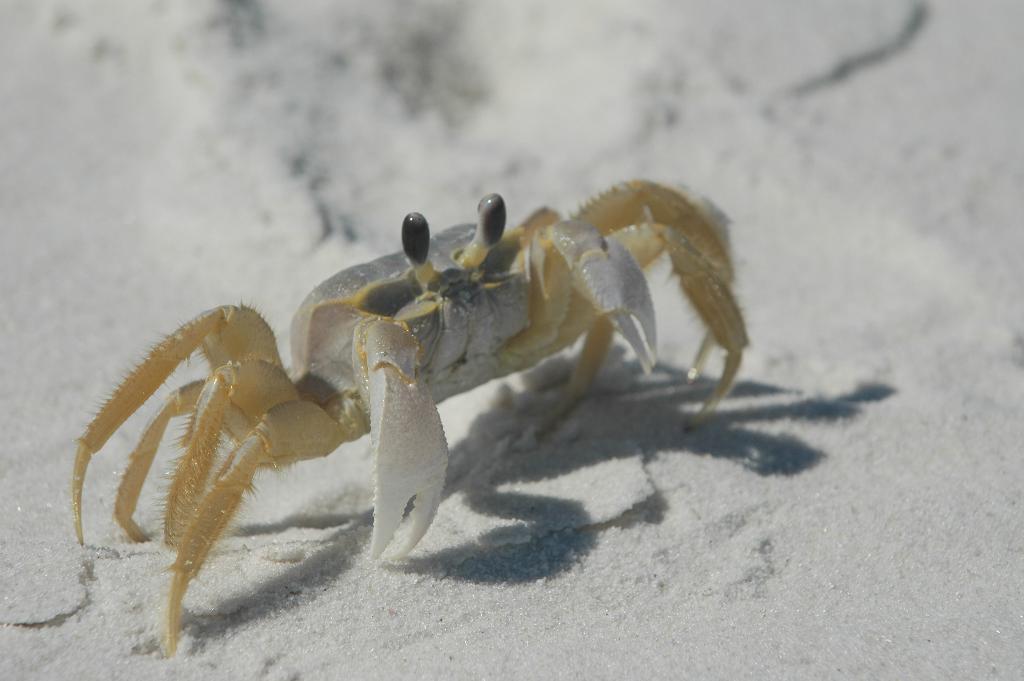Can you describe this image briefly? The picture consists of a crab, crawling in the sand. 